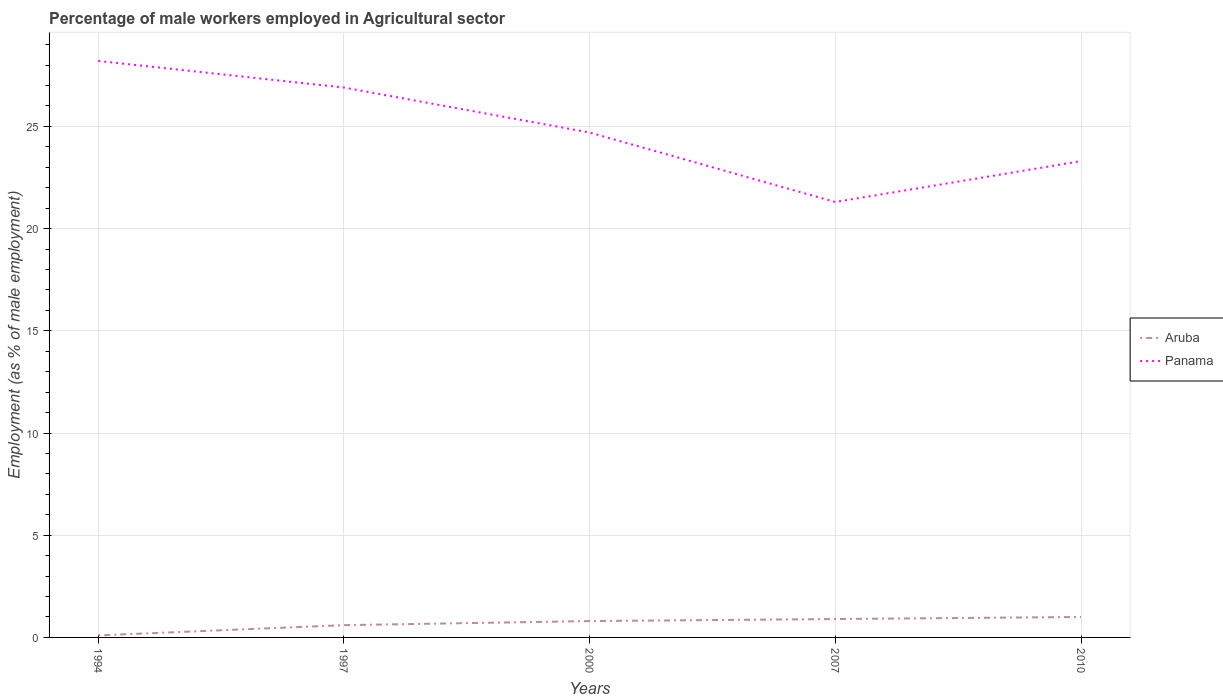How many different coloured lines are there?
Provide a succinct answer. 2. Is the number of lines equal to the number of legend labels?
Provide a succinct answer. Yes. Across all years, what is the maximum percentage of male workers employed in Agricultural sector in Aruba?
Give a very brief answer. 0.1. What is the total percentage of male workers employed in Agricultural sector in Panama in the graph?
Provide a short and direct response. -2. What is the difference between the highest and the second highest percentage of male workers employed in Agricultural sector in Panama?
Your answer should be compact. 6.9. What is the difference between the highest and the lowest percentage of male workers employed in Agricultural sector in Panama?
Provide a short and direct response. 2. Does the graph contain grids?
Provide a short and direct response. Yes. Where does the legend appear in the graph?
Make the answer very short. Center right. What is the title of the graph?
Your answer should be compact. Percentage of male workers employed in Agricultural sector. What is the label or title of the X-axis?
Offer a terse response. Years. What is the label or title of the Y-axis?
Provide a succinct answer. Employment (as % of male employment). What is the Employment (as % of male employment) in Aruba in 1994?
Give a very brief answer. 0.1. What is the Employment (as % of male employment) in Panama in 1994?
Provide a succinct answer. 28.2. What is the Employment (as % of male employment) in Aruba in 1997?
Make the answer very short. 0.6. What is the Employment (as % of male employment) in Panama in 1997?
Offer a very short reply. 26.9. What is the Employment (as % of male employment) in Aruba in 2000?
Your response must be concise. 0.8. What is the Employment (as % of male employment) in Panama in 2000?
Your answer should be compact. 24.7. What is the Employment (as % of male employment) in Aruba in 2007?
Make the answer very short. 0.9. What is the Employment (as % of male employment) of Panama in 2007?
Make the answer very short. 21.3. What is the Employment (as % of male employment) in Aruba in 2010?
Make the answer very short. 1. What is the Employment (as % of male employment) in Panama in 2010?
Your response must be concise. 23.3. Across all years, what is the maximum Employment (as % of male employment) of Panama?
Your answer should be compact. 28.2. Across all years, what is the minimum Employment (as % of male employment) in Aruba?
Provide a succinct answer. 0.1. Across all years, what is the minimum Employment (as % of male employment) of Panama?
Offer a terse response. 21.3. What is the total Employment (as % of male employment) in Aruba in the graph?
Provide a short and direct response. 3.4. What is the total Employment (as % of male employment) in Panama in the graph?
Make the answer very short. 124.4. What is the difference between the Employment (as % of male employment) in Aruba in 1994 and that in 1997?
Your answer should be compact. -0.5. What is the difference between the Employment (as % of male employment) of Aruba in 1994 and that in 2010?
Ensure brevity in your answer.  -0.9. What is the difference between the Employment (as % of male employment) in Panama in 1994 and that in 2010?
Your answer should be very brief. 4.9. What is the difference between the Employment (as % of male employment) of Aruba in 1997 and that in 2000?
Provide a short and direct response. -0.2. What is the difference between the Employment (as % of male employment) in Aruba in 1997 and that in 2007?
Make the answer very short. -0.3. What is the difference between the Employment (as % of male employment) of Panama in 1997 and that in 2010?
Provide a short and direct response. 3.6. What is the difference between the Employment (as % of male employment) of Aruba in 2000 and that in 2007?
Provide a succinct answer. -0.1. What is the difference between the Employment (as % of male employment) in Panama in 2000 and that in 2007?
Give a very brief answer. 3.4. What is the difference between the Employment (as % of male employment) of Aruba in 2000 and that in 2010?
Provide a succinct answer. -0.2. What is the difference between the Employment (as % of male employment) of Aruba in 2007 and that in 2010?
Make the answer very short. -0.1. What is the difference between the Employment (as % of male employment) of Aruba in 1994 and the Employment (as % of male employment) of Panama in 1997?
Provide a short and direct response. -26.8. What is the difference between the Employment (as % of male employment) in Aruba in 1994 and the Employment (as % of male employment) in Panama in 2000?
Provide a short and direct response. -24.6. What is the difference between the Employment (as % of male employment) of Aruba in 1994 and the Employment (as % of male employment) of Panama in 2007?
Your answer should be very brief. -21.2. What is the difference between the Employment (as % of male employment) in Aruba in 1994 and the Employment (as % of male employment) in Panama in 2010?
Give a very brief answer. -23.2. What is the difference between the Employment (as % of male employment) of Aruba in 1997 and the Employment (as % of male employment) of Panama in 2000?
Give a very brief answer. -24.1. What is the difference between the Employment (as % of male employment) in Aruba in 1997 and the Employment (as % of male employment) in Panama in 2007?
Your answer should be compact. -20.7. What is the difference between the Employment (as % of male employment) of Aruba in 1997 and the Employment (as % of male employment) of Panama in 2010?
Ensure brevity in your answer.  -22.7. What is the difference between the Employment (as % of male employment) of Aruba in 2000 and the Employment (as % of male employment) of Panama in 2007?
Make the answer very short. -20.5. What is the difference between the Employment (as % of male employment) in Aruba in 2000 and the Employment (as % of male employment) in Panama in 2010?
Offer a terse response. -22.5. What is the difference between the Employment (as % of male employment) in Aruba in 2007 and the Employment (as % of male employment) in Panama in 2010?
Your answer should be compact. -22.4. What is the average Employment (as % of male employment) of Aruba per year?
Offer a terse response. 0.68. What is the average Employment (as % of male employment) in Panama per year?
Give a very brief answer. 24.88. In the year 1994, what is the difference between the Employment (as % of male employment) in Aruba and Employment (as % of male employment) in Panama?
Keep it short and to the point. -28.1. In the year 1997, what is the difference between the Employment (as % of male employment) of Aruba and Employment (as % of male employment) of Panama?
Provide a short and direct response. -26.3. In the year 2000, what is the difference between the Employment (as % of male employment) of Aruba and Employment (as % of male employment) of Panama?
Provide a short and direct response. -23.9. In the year 2007, what is the difference between the Employment (as % of male employment) of Aruba and Employment (as % of male employment) of Panama?
Your response must be concise. -20.4. In the year 2010, what is the difference between the Employment (as % of male employment) in Aruba and Employment (as % of male employment) in Panama?
Your response must be concise. -22.3. What is the ratio of the Employment (as % of male employment) of Aruba in 1994 to that in 1997?
Provide a short and direct response. 0.17. What is the ratio of the Employment (as % of male employment) of Panama in 1994 to that in 1997?
Your response must be concise. 1.05. What is the ratio of the Employment (as % of male employment) of Panama in 1994 to that in 2000?
Keep it short and to the point. 1.14. What is the ratio of the Employment (as % of male employment) in Aruba in 1994 to that in 2007?
Your answer should be very brief. 0.11. What is the ratio of the Employment (as % of male employment) of Panama in 1994 to that in 2007?
Give a very brief answer. 1.32. What is the ratio of the Employment (as % of male employment) of Aruba in 1994 to that in 2010?
Provide a succinct answer. 0.1. What is the ratio of the Employment (as % of male employment) of Panama in 1994 to that in 2010?
Make the answer very short. 1.21. What is the ratio of the Employment (as % of male employment) in Panama in 1997 to that in 2000?
Ensure brevity in your answer.  1.09. What is the ratio of the Employment (as % of male employment) of Panama in 1997 to that in 2007?
Your answer should be compact. 1.26. What is the ratio of the Employment (as % of male employment) of Aruba in 1997 to that in 2010?
Offer a very short reply. 0.6. What is the ratio of the Employment (as % of male employment) of Panama in 1997 to that in 2010?
Ensure brevity in your answer.  1.15. What is the ratio of the Employment (as % of male employment) in Aruba in 2000 to that in 2007?
Offer a terse response. 0.89. What is the ratio of the Employment (as % of male employment) in Panama in 2000 to that in 2007?
Your response must be concise. 1.16. What is the ratio of the Employment (as % of male employment) of Aruba in 2000 to that in 2010?
Offer a terse response. 0.8. What is the ratio of the Employment (as % of male employment) of Panama in 2000 to that in 2010?
Your response must be concise. 1.06. What is the ratio of the Employment (as % of male employment) in Panama in 2007 to that in 2010?
Give a very brief answer. 0.91. What is the difference between the highest and the second highest Employment (as % of male employment) of Aruba?
Provide a succinct answer. 0.1. What is the difference between the highest and the second highest Employment (as % of male employment) of Panama?
Ensure brevity in your answer.  1.3. What is the difference between the highest and the lowest Employment (as % of male employment) of Aruba?
Your answer should be very brief. 0.9. What is the difference between the highest and the lowest Employment (as % of male employment) in Panama?
Your response must be concise. 6.9. 